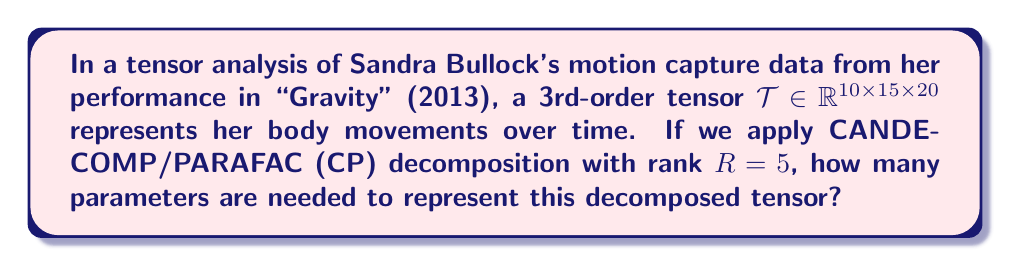Can you answer this question? Let's approach this step-by-step:

1) The CP decomposition of a 3rd-order tensor $\mathcal{T} \in \mathbb{R}^{I \times J \times K}$ with rank $R$ is given by:

   $$\mathcal{T} \approx \sum_{r=1}^R a_r \circ b_r \circ c_r$$

   where $a_r \in \mathbb{R}^I$, $b_r \in \mathbb{R}^J$, and $c_r \in \mathbb{R}^K$ are vectors, and $\circ$ denotes the outer product.

2) In this case, we have:
   $I = 10$ (first dimension)
   $J = 15$ (second dimension)
   $K = 20$ (third dimension)
   $R = 5$ (rank of decomposition)

3) For each $r$ (from 1 to $R$), we need:
   - $I = 10$ parameters for $a_r$
   - $J = 15$ parameters for $b_r$
   - $K = 20$ parameters for $c_r$

4) The total number of parameters for each $r$ is thus:
   $10 + 15 + 20 = 45$

5) Since we have $R = 5$ components, the total number of parameters is:
   $45 \times 5 = 225$

Therefore, 225 parameters are needed to represent the decomposed tensor.
Answer: 225 